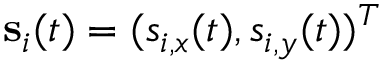Convert formula to latex. <formula><loc_0><loc_0><loc_500><loc_500>\mathbf s _ { i } ( t ) = ( s _ { i , x } ( t ) , s _ { i , y } ( t ) ) ^ { T }</formula> 